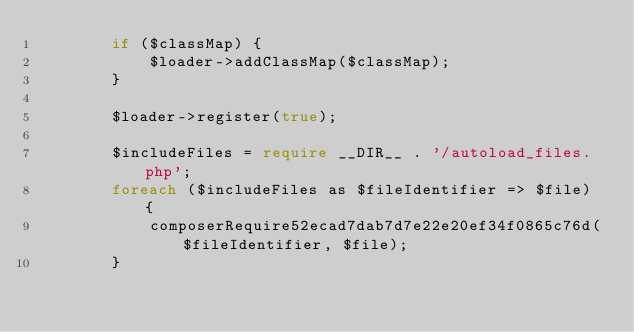Convert code to text. <code><loc_0><loc_0><loc_500><loc_500><_PHP_>        if ($classMap) {
            $loader->addClassMap($classMap);
        }

        $loader->register(true);

        $includeFiles = require __DIR__ . '/autoload_files.php';
        foreach ($includeFiles as $fileIdentifier => $file) {
            composerRequire52ecad7dab7d7e22e20ef34f0865c76d($fileIdentifier, $file);
        }
</code> 